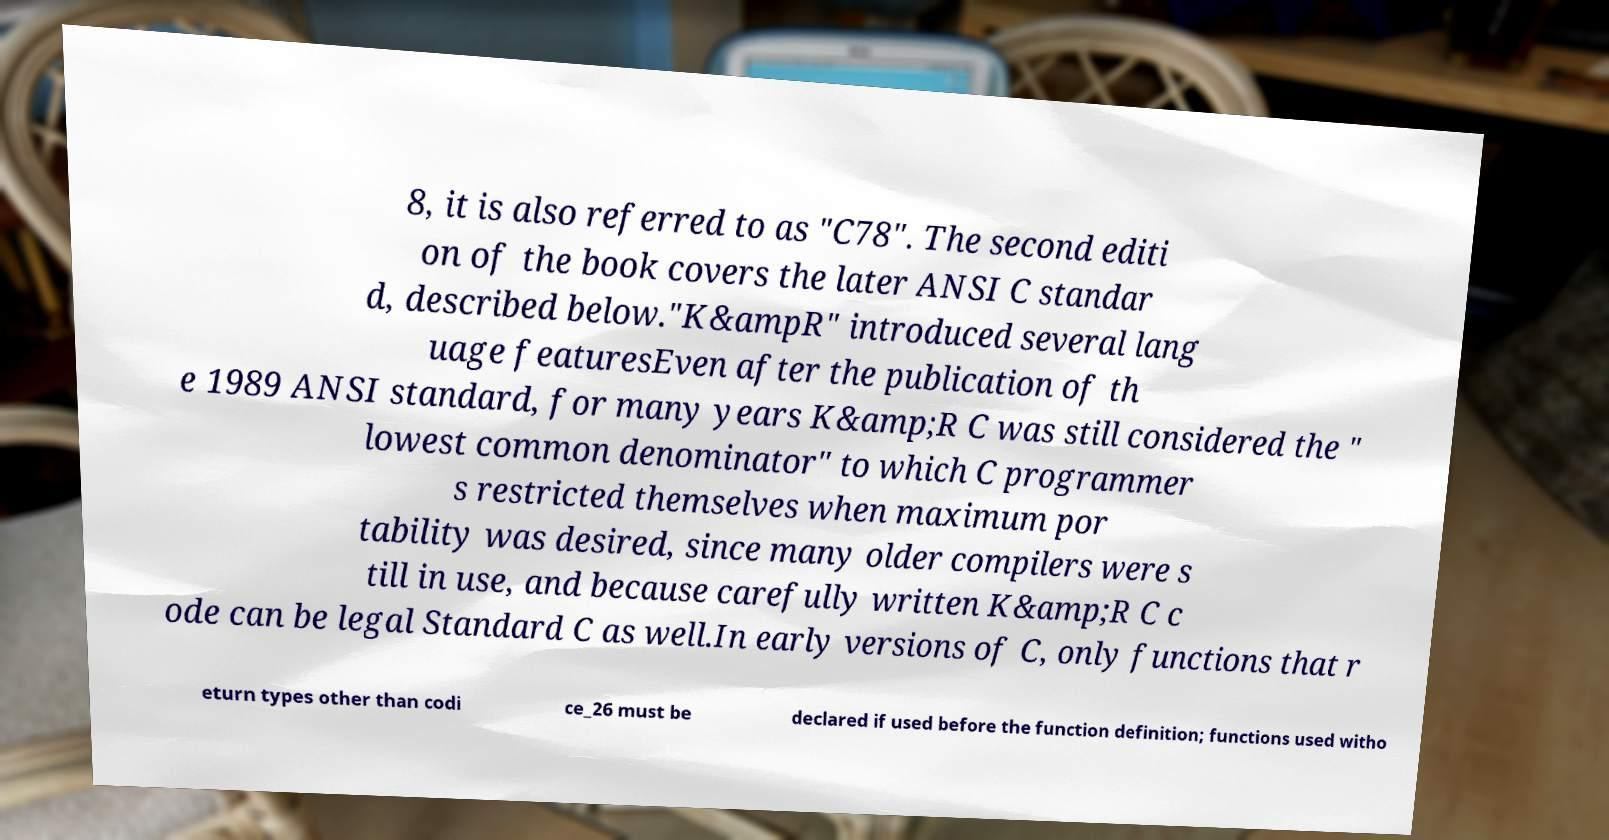Can you read and provide the text displayed in the image?This photo seems to have some interesting text. Can you extract and type it out for me? 8, it is also referred to as "C78". The second editi on of the book covers the later ANSI C standar d, described below."K&ampR" introduced several lang uage featuresEven after the publication of th e 1989 ANSI standard, for many years K&amp;R C was still considered the " lowest common denominator" to which C programmer s restricted themselves when maximum por tability was desired, since many older compilers were s till in use, and because carefully written K&amp;R C c ode can be legal Standard C as well.In early versions of C, only functions that r eturn types other than codi ce_26 must be declared if used before the function definition; functions used witho 